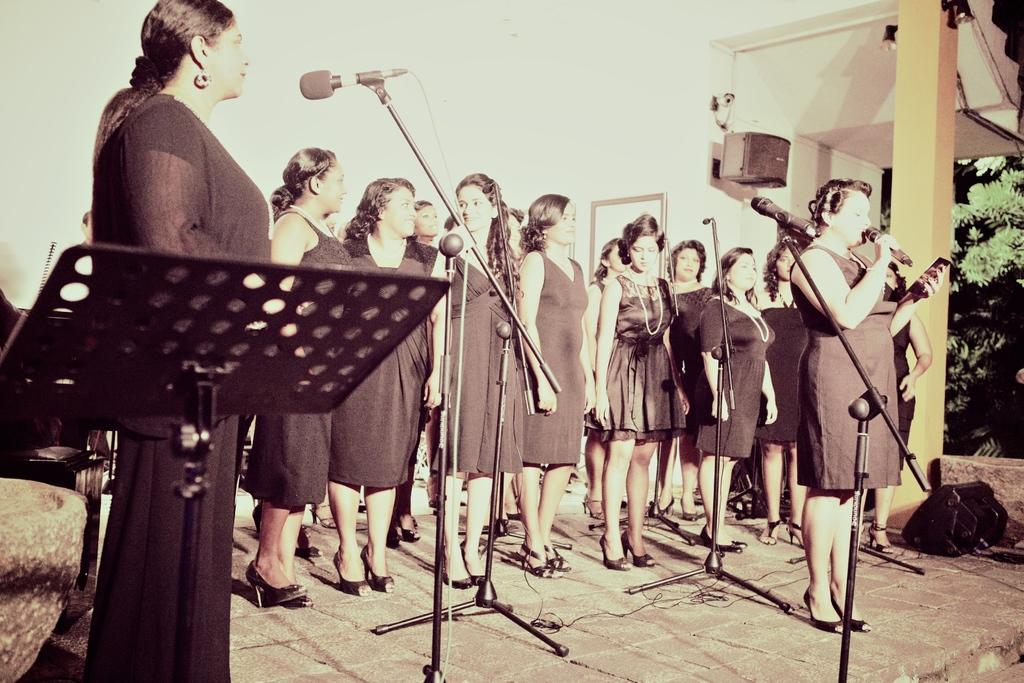How would you summarize this image in a sentence or two? In this image we can see a group of women standing on the floor. In that a woman is holding a mic and an object. We can also see the speaker boxes, a pillar, mikes on the stands, some trees, a speaker stand, some wires and a wall. 